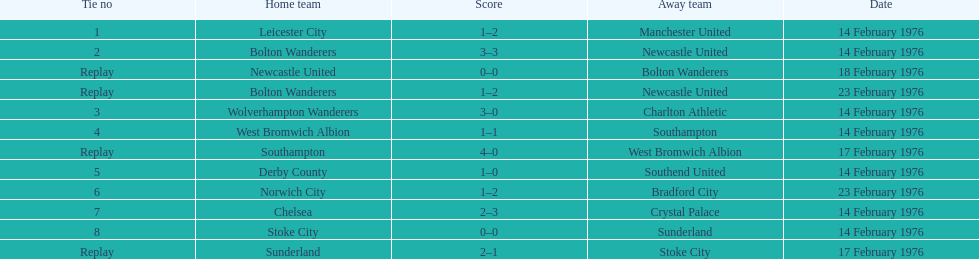Parse the full table. {'header': ['Tie no', 'Home team', 'Score', 'Away team', 'Date'], 'rows': [['1', 'Leicester City', '1–2', 'Manchester United', '14 February 1976'], ['2', 'Bolton Wanderers', '3–3', 'Newcastle United', '14 February 1976'], ['Replay', 'Newcastle United', '0–0', 'Bolton Wanderers', '18 February 1976'], ['Replay', 'Bolton Wanderers', '1–2', 'Newcastle United', '23 February 1976'], ['3', 'Wolverhampton Wanderers', '3–0', 'Charlton Athletic', '14 February 1976'], ['4', 'West Bromwich Albion', '1–1', 'Southampton', '14 February 1976'], ['Replay', 'Southampton', '4–0', 'West Bromwich Albion', '17 February 1976'], ['5', 'Derby County', '1–0', 'Southend United', '14 February 1976'], ['6', 'Norwich City', '1–2', 'Bradford City', '23 February 1976'], ['7', 'Chelsea', '2–3', 'Crystal Palace', '14 February 1976'], ['8', 'Stoke City', '0–0', 'Sunderland', '14 February 1976'], ['Replay', 'Sunderland', '2–1', 'Stoke City', '17 February 1976']]} On the same day as leicester city and manchester united, which teams competed? Bolton Wanderers, Newcastle United. 